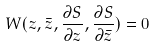Convert formula to latex. <formula><loc_0><loc_0><loc_500><loc_500>W ( z , \bar { z } , \frac { \partial { S } } { \partial { z } } , \frac { \partial { S } } { \partial \bar { z } } ) = 0</formula> 